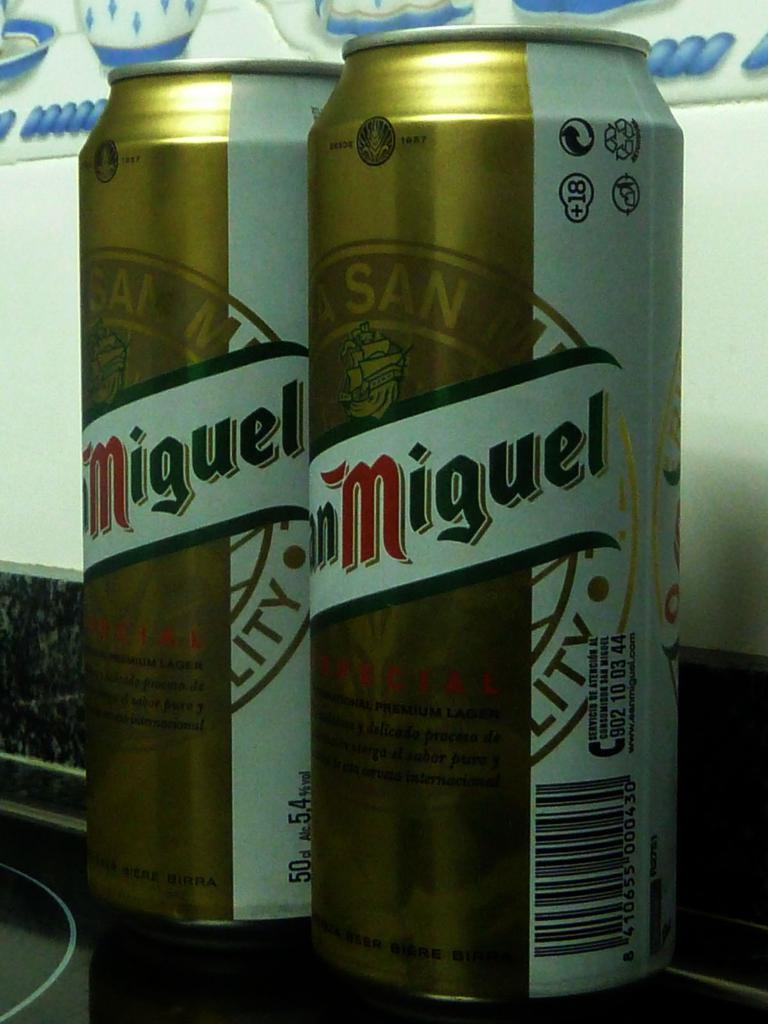<image>
Offer a succinct explanation of the picture presented. Two cans of  San Miguel' beer are shown in the image. 